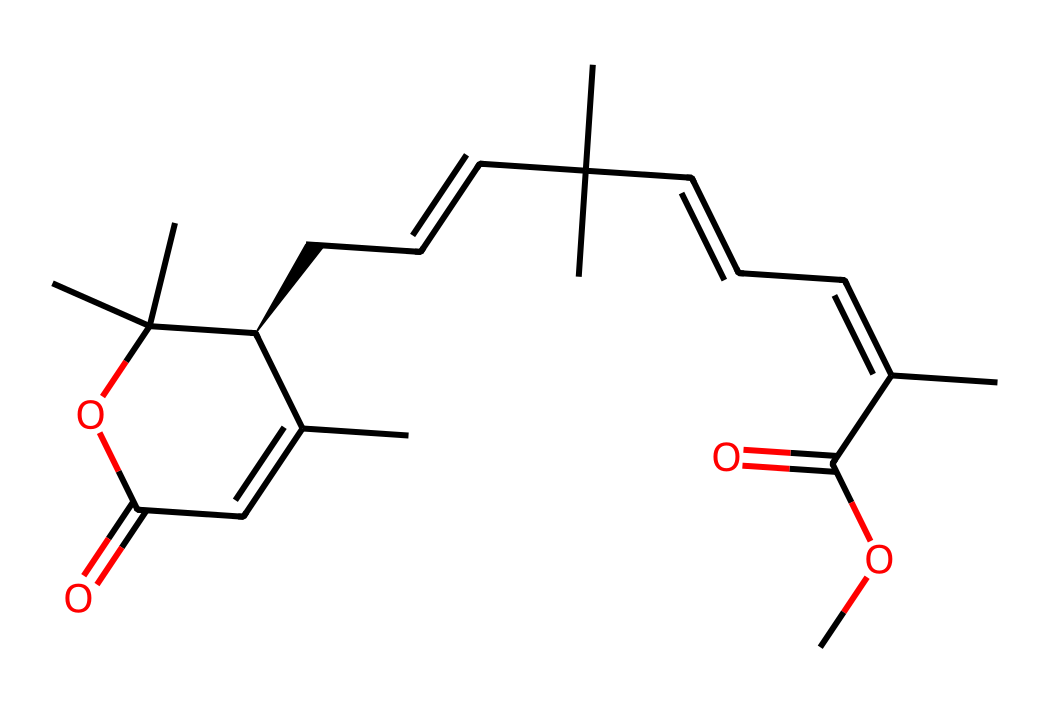How many carbon atoms are present in the structure? By analyzing the SMILES representation, we can count the number of carbon atoms denoted by 'C'. As we go through the structure, we find a total of 24 carbon atoms.
Answer: 24 What functional groups are present in pyrethrin? Looking at the SMILES representation, the presence of "C(=O)" indicates carbonyl functional groups, while "OC" shows the presence of ester groups. This reveals that both carbonyl and ester functional groups are present in pyrethrin.
Answer: carbonyl and ester What is the molecular formula derived from the SMILES? To derive the molecular formula, we can tally the types of atoms as represented in the SMILES. There are 24 carbons, 32 hydrogens, and 4 oxygens, leading us to the formula C24H32O4.
Answer: C24H32O4 What type of pesticide is pyrethrin classified as? Pyrethrin is classified as a natural insecticide derived from chrysanthemum flowers and is known to be a contact insecticide, meaning it affects insects upon direct application.
Answer: natural insecticide What is the significance of the double bonds in this structure? The presence of double bonds in the structure (notably in the cyclic and aliphatic regions) contributes to the insecticidal activity by altering the stability and reactivity of the molecule, making it more effective against target pests.
Answer: insecticidal activity How many rings are present in the molecular structure? By examining the rings and counting the cycles represented in the SMILES, we can identify that there are two distinct rings in the pyrethrin structure.
Answer: 2 